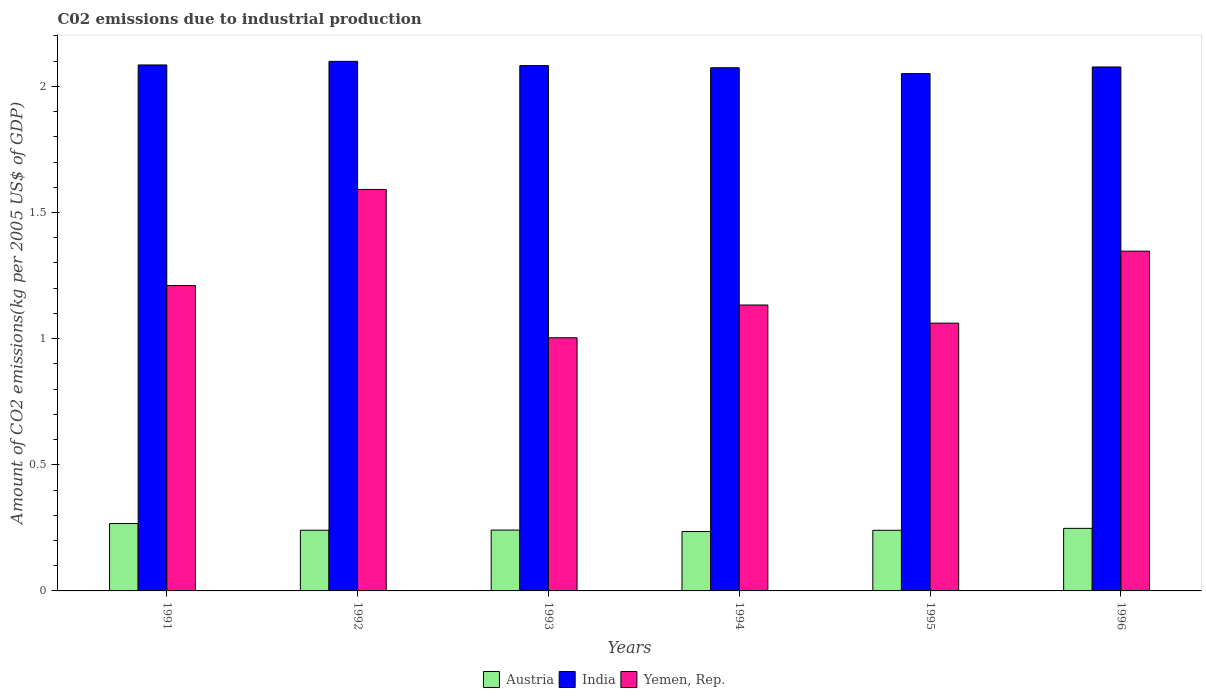How many different coloured bars are there?
Your answer should be very brief. 3. Are the number of bars on each tick of the X-axis equal?
Your response must be concise. Yes. What is the amount of CO2 emitted due to industrial production in Yemen, Rep. in 1994?
Offer a very short reply. 1.13. Across all years, what is the maximum amount of CO2 emitted due to industrial production in Yemen, Rep.?
Provide a succinct answer. 1.59. Across all years, what is the minimum amount of CO2 emitted due to industrial production in Yemen, Rep.?
Make the answer very short. 1. What is the total amount of CO2 emitted due to industrial production in India in the graph?
Provide a succinct answer. 12.47. What is the difference between the amount of CO2 emitted due to industrial production in India in 1992 and that in 1994?
Ensure brevity in your answer.  0.03. What is the difference between the amount of CO2 emitted due to industrial production in Austria in 1991 and the amount of CO2 emitted due to industrial production in India in 1995?
Your response must be concise. -1.78. What is the average amount of CO2 emitted due to industrial production in Yemen, Rep. per year?
Provide a short and direct response. 1.22. In the year 1992, what is the difference between the amount of CO2 emitted due to industrial production in India and amount of CO2 emitted due to industrial production in Austria?
Your response must be concise. 1.86. What is the ratio of the amount of CO2 emitted due to industrial production in Yemen, Rep. in 1992 to that in 1994?
Provide a short and direct response. 1.4. Is the amount of CO2 emitted due to industrial production in Yemen, Rep. in 1992 less than that in 1994?
Make the answer very short. No. Is the difference between the amount of CO2 emitted due to industrial production in India in 1991 and 1996 greater than the difference between the amount of CO2 emitted due to industrial production in Austria in 1991 and 1996?
Keep it short and to the point. No. What is the difference between the highest and the second highest amount of CO2 emitted due to industrial production in India?
Provide a succinct answer. 0.01. What is the difference between the highest and the lowest amount of CO2 emitted due to industrial production in Austria?
Provide a succinct answer. 0.03. In how many years, is the amount of CO2 emitted due to industrial production in Yemen, Rep. greater than the average amount of CO2 emitted due to industrial production in Yemen, Rep. taken over all years?
Your answer should be compact. 2. What does the 3rd bar from the left in 1996 represents?
Your answer should be very brief. Yemen, Rep. Is it the case that in every year, the sum of the amount of CO2 emitted due to industrial production in India and amount of CO2 emitted due to industrial production in Yemen, Rep. is greater than the amount of CO2 emitted due to industrial production in Austria?
Your answer should be compact. Yes. How many bars are there?
Keep it short and to the point. 18. Are all the bars in the graph horizontal?
Provide a short and direct response. No. How many years are there in the graph?
Provide a succinct answer. 6. What is the difference between two consecutive major ticks on the Y-axis?
Offer a terse response. 0.5. Does the graph contain any zero values?
Give a very brief answer. No. Where does the legend appear in the graph?
Provide a succinct answer. Bottom center. How are the legend labels stacked?
Your answer should be very brief. Horizontal. What is the title of the graph?
Ensure brevity in your answer.  C02 emissions due to industrial production. What is the label or title of the Y-axis?
Provide a succinct answer. Amount of CO2 emissions(kg per 2005 US$ of GDP). What is the Amount of CO2 emissions(kg per 2005 US$ of GDP) of Austria in 1991?
Offer a terse response. 0.27. What is the Amount of CO2 emissions(kg per 2005 US$ of GDP) in India in 1991?
Provide a succinct answer. 2.08. What is the Amount of CO2 emissions(kg per 2005 US$ of GDP) of Yemen, Rep. in 1991?
Offer a terse response. 1.21. What is the Amount of CO2 emissions(kg per 2005 US$ of GDP) in Austria in 1992?
Your answer should be compact. 0.24. What is the Amount of CO2 emissions(kg per 2005 US$ of GDP) in India in 1992?
Offer a terse response. 2.1. What is the Amount of CO2 emissions(kg per 2005 US$ of GDP) in Yemen, Rep. in 1992?
Keep it short and to the point. 1.59. What is the Amount of CO2 emissions(kg per 2005 US$ of GDP) in Austria in 1993?
Give a very brief answer. 0.24. What is the Amount of CO2 emissions(kg per 2005 US$ of GDP) in India in 1993?
Give a very brief answer. 2.08. What is the Amount of CO2 emissions(kg per 2005 US$ of GDP) in Yemen, Rep. in 1993?
Your answer should be compact. 1. What is the Amount of CO2 emissions(kg per 2005 US$ of GDP) in Austria in 1994?
Offer a terse response. 0.24. What is the Amount of CO2 emissions(kg per 2005 US$ of GDP) in India in 1994?
Make the answer very short. 2.07. What is the Amount of CO2 emissions(kg per 2005 US$ of GDP) in Yemen, Rep. in 1994?
Give a very brief answer. 1.13. What is the Amount of CO2 emissions(kg per 2005 US$ of GDP) in Austria in 1995?
Keep it short and to the point. 0.24. What is the Amount of CO2 emissions(kg per 2005 US$ of GDP) in India in 1995?
Your answer should be very brief. 2.05. What is the Amount of CO2 emissions(kg per 2005 US$ of GDP) in Yemen, Rep. in 1995?
Ensure brevity in your answer.  1.06. What is the Amount of CO2 emissions(kg per 2005 US$ of GDP) of Austria in 1996?
Offer a very short reply. 0.25. What is the Amount of CO2 emissions(kg per 2005 US$ of GDP) of India in 1996?
Your answer should be very brief. 2.08. What is the Amount of CO2 emissions(kg per 2005 US$ of GDP) of Yemen, Rep. in 1996?
Offer a terse response. 1.35. Across all years, what is the maximum Amount of CO2 emissions(kg per 2005 US$ of GDP) in Austria?
Your answer should be very brief. 0.27. Across all years, what is the maximum Amount of CO2 emissions(kg per 2005 US$ of GDP) of India?
Give a very brief answer. 2.1. Across all years, what is the maximum Amount of CO2 emissions(kg per 2005 US$ of GDP) in Yemen, Rep.?
Offer a very short reply. 1.59. Across all years, what is the minimum Amount of CO2 emissions(kg per 2005 US$ of GDP) in Austria?
Ensure brevity in your answer.  0.24. Across all years, what is the minimum Amount of CO2 emissions(kg per 2005 US$ of GDP) in India?
Provide a succinct answer. 2.05. Across all years, what is the minimum Amount of CO2 emissions(kg per 2005 US$ of GDP) in Yemen, Rep.?
Ensure brevity in your answer.  1. What is the total Amount of CO2 emissions(kg per 2005 US$ of GDP) in Austria in the graph?
Provide a short and direct response. 1.47. What is the total Amount of CO2 emissions(kg per 2005 US$ of GDP) in India in the graph?
Your response must be concise. 12.47. What is the total Amount of CO2 emissions(kg per 2005 US$ of GDP) in Yemen, Rep. in the graph?
Give a very brief answer. 7.35. What is the difference between the Amount of CO2 emissions(kg per 2005 US$ of GDP) of Austria in 1991 and that in 1992?
Keep it short and to the point. 0.03. What is the difference between the Amount of CO2 emissions(kg per 2005 US$ of GDP) in India in 1991 and that in 1992?
Your answer should be compact. -0.01. What is the difference between the Amount of CO2 emissions(kg per 2005 US$ of GDP) in Yemen, Rep. in 1991 and that in 1992?
Your response must be concise. -0.38. What is the difference between the Amount of CO2 emissions(kg per 2005 US$ of GDP) in Austria in 1991 and that in 1993?
Give a very brief answer. 0.03. What is the difference between the Amount of CO2 emissions(kg per 2005 US$ of GDP) in India in 1991 and that in 1993?
Your answer should be compact. 0. What is the difference between the Amount of CO2 emissions(kg per 2005 US$ of GDP) of Yemen, Rep. in 1991 and that in 1993?
Keep it short and to the point. 0.21. What is the difference between the Amount of CO2 emissions(kg per 2005 US$ of GDP) of Austria in 1991 and that in 1994?
Provide a short and direct response. 0.03. What is the difference between the Amount of CO2 emissions(kg per 2005 US$ of GDP) in India in 1991 and that in 1994?
Your answer should be very brief. 0.01. What is the difference between the Amount of CO2 emissions(kg per 2005 US$ of GDP) of Yemen, Rep. in 1991 and that in 1994?
Your answer should be very brief. 0.08. What is the difference between the Amount of CO2 emissions(kg per 2005 US$ of GDP) of Austria in 1991 and that in 1995?
Provide a succinct answer. 0.03. What is the difference between the Amount of CO2 emissions(kg per 2005 US$ of GDP) in India in 1991 and that in 1995?
Make the answer very short. 0.03. What is the difference between the Amount of CO2 emissions(kg per 2005 US$ of GDP) of Yemen, Rep. in 1991 and that in 1995?
Keep it short and to the point. 0.15. What is the difference between the Amount of CO2 emissions(kg per 2005 US$ of GDP) in Austria in 1991 and that in 1996?
Give a very brief answer. 0.02. What is the difference between the Amount of CO2 emissions(kg per 2005 US$ of GDP) of India in 1991 and that in 1996?
Keep it short and to the point. 0.01. What is the difference between the Amount of CO2 emissions(kg per 2005 US$ of GDP) in Yemen, Rep. in 1991 and that in 1996?
Provide a succinct answer. -0.14. What is the difference between the Amount of CO2 emissions(kg per 2005 US$ of GDP) of Austria in 1992 and that in 1993?
Ensure brevity in your answer.  -0. What is the difference between the Amount of CO2 emissions(kg per 2005 US$ of GDP) in India in 1992 and that in 1993?
Give a very brief answer. 0.02. What is the difference between the Amount of CO2 emissions(kg per 2005 US$ of GDP) in Yemen, Rep. in 1992 and that in 1993?
Give a very brief answer. 0.59. What is the difference between the Amount of CO2 emissions(kg per 2005 US$ of GDP) in Austria in 1992 and that in 1994?
Offer a terse response. 0.01. What is the difference between the Amount of CO2 emissions(kg per 2005 US$ of GDP) in India in 1992 and that in 1994?
Your response must be concise. 0.03. What is the difference between the Amount of CO2 emissions(kg per 2005 US$ of GDP) of Yemen, Rep. in 1992 and that in 1994?
Offer a terse response. 0.46. What is the difference between the Amount of CO2 emissions(kg per 2005 US$ of GDP) in India in 1992 and that in 1995?
Provide a succinct answer. 0.05. What is the difference between the Amount of CO2 emissions(kg per 2005 US$ of GDP) of Yemen, Rep. in 1992 and that in 1995?
Your response must be concise. 0.53. What is the difference between the Amount of CO2 emissions(kg per 2005 US$ of GDP) of Austria in 1992 and that in 1996?
Keep it short and to the point. -0.01. What is the difference between the Amount of CO2 emissions(kg per 2005 US$ of GDP) in India in 1992 and that in 1996?
Your answer should be compact. 0.02. What is the difference between the Amount of CO2 emissions(kg per 2005 US$ of GDP) in Yemen, Rep. in 1992 and that in 1996?
Ensure brevity in your answer.  0.24. What is the difference between the Amount of CO2 emissions(kg per 2005 US$ of GDP) in Austria in 1993 and that in 1994?
Keep it short and to the point. 0.01. What is the difference between the Amount of CO2 emissions(kg per 2005 US$ of GDP) of India in 1993 and that in 1994?
Provide a succinct answer. 0.01. What is the difference between the Amount of CO2 emissions(kg per 2005 US$ of GDP) in Yemen, Rep. in 1993 and that in 1994?
Offer a terse response. -0.13. What is the difference between the Amount of CO2 emissions(kg per 2005 US$ of GDP) in India in 1993 and that in 1995?
Make the answer very short. 0.03. What is the difference between the Amount of CO2 emissions(kg per 2005 US$ of GDP) in Yemen, Rep. in 1993 and that in 1995?
Provide a short and direct response. -0.06. What is the difference between the Amount of CO2 emissions(kg per 2005 US$ of GDP) in Austria in 1993 and that in 1996?
Provide a short and direct response. -0.01. What is the difference between the Amount of CO2 emissions(kg per 2005 US$ of GDP) in India in 1993 and that in 1996?
Ensure brevity in your answer.  0.01. What is the difference between the Amount of CO2 emissions(kg per 2005 US$ of GDP) in Yemen, Rep. in 1993 and that in 1996?
Make the answer very short. -0.34. What is the difference between the Amount of CO2 emissions(kg per 2005 US$ of GDP) in Austria in 1994 and that in 1995?
Offer a very short reply. -0. What is the difference between the Amount of CO2 emissions(kg per 2005 US$ of GDP) in India in 1994 and that in 1995?
Offer a terse response. 0.02. What is the difference between the Amount of CO2 emissions(kg per 2005 US$ of GDP) in Yemen, Rep. in 1994 and that in 1995?
Provide a short and direct response. 0.07. What is the difference between the Amount of CO2 emissions(kg per 2005 US$ of GDP) of Austria in 1994 and that in 1996?
Your answer should be very brief. -0.01. What is the difference between the Amount of CO2 emissions(kg per 2005 US$ of GDP) of India in 1994 and that in 1996?
Your answer should be very brief. -0. What is the difference between the Amount of CO2 emissions(kg per 2005 US$ of GDP) of Yemen, Rep. in 1994 and that in 1996?
Offer a terse response. -0.21. What is the difference between the Amount of CO2 emissions(kg per 2005 US$ of GDP) in Austria in 1995 and that in 1996?
Your answer should be compact. -0.01. What is the difference between the Amount of CO2 emissions(kg per 2005 US$ of GDP) in India in 1995 and that in 1996?
Give a very brief answer. -0.03. What is the difference between the Amount of CO2 emissions(kg per 2005 US$ of GDP) of Yemen, Rep. in 1995 and that in 1996?
Your response must be concise. -0.29. What is the difference between the Amount of CO2 emissions(kg per 2005 US$ of GDP) in Austria in 1991 and the Amount of CO2 emissions(kg per 2005 US$ of GDP) in India in 1992?
Keep it short and to the point. -1.83. What is the difference between the Amount of CO2 emissions(kg per 2005 US$ of GDP) in Austria in 1991 and the Amount of CO2 emissions(kg per 2005 US$ of GDP) in Yemen, Rep. in 1992?
Your answer should be very brief. -1.32. What is the difference between the Amount of CO2 emissions(kg per 2005 US$ of GDP) of India in 1991 and the Amount of CO2 emissions(kg per 2005 US$ of GDP) of Yemen, Rep. in 1992?
Provide a short and direct response. 0.49. What is the difference between the Amount of CO2 emissions(kg per 2005 US$ of GDP) in Austria in 1991 and the Amount of CO2 emissions(kg per 2005 US$ of GDP) in India in 1993?
Your answer should be very brief. -1.81. What is the difference between the Amount of CO2 emissions(kg per 2005 US$ of GDP) of Austria in 1991 and the Amount of CO2 emissions(kg per 2005 US$ of GDP) of Yemen, Rep. in 1993?
Your answer should be very brief. -0.74. What is the difference between the Amount of CO2 emissions(kg per 2005 US$ of GDP) in India in 1991 and the Amount of CO2 emissions(kg per 2005 US$ of GDP) in Yemen, Rep. in 1993?
Your answer should be compact. 1.08. What is the difference between the Amount of CO2 emissions(kg per 2005 US$ of GDP) in Austria in 1991 and the Amount of CO2 emissions(kg per 2005 US$ of GDP) in India in 1994?
Ensure brevity in your answer.  -1.81. What is the difference between the Amount of CO2 emissions(kg per 2005 US$ of GDP) in Austria in 1991 and the Amount of CO2 emissions(kg per 2005 US$ of GDP) in Yemen, Rep. in 1994?
Keep it short and to the point. -0.87. What is the difference between the Amount of CO2 emissions(kg per 2005 US$ of GDP) of India in 1991 and the Amount of CO2 emissions(kg per 2005 US$ of GDP) of Yemen, Rep. in 1994?
Make the answer very short. 0.95. What is the difference between the Amount of CO2 emissions(kg per 2005 US$ of GDP) in Austria in 1991 and the Amount of CO2 emissions(kg per 2005 US$ of GDP) in India in 1995?
Your answer should be compact. -1.78. What is the difference between the Amount of CO2 emissions(kg per 2005 US$ of GDP) in Austria in 1991 and the Amount of CO2 emissions(kg per 2005 US$ of GDP) in Yemen, Rep. in 1995?
Offer a terse response. -0.79. What is the difference between the Amount of CO2 emissions(kg per 2005 US$ of GDP) of India in 1991 and the Amount of CO2 emissions(kg per 2005 US$ of GDP) of Yemen, Rep. in 1995?
Provide a short and direct response. 1.02. What is the difference between the Amount of CO2 emissions(kg per 2005 US$ of GDP) of Austria in 1991 and the Amount of CO2 emissions(kg per 2005 US$ of GDP) of India in 1996?
Ensure brevity in your answer.  -1.81. What is the difference between the Amount of CO2 emissions(kg per 2005 US$ of GDP) of Austria in 1991 and the Amount of CO2 emissions(kg per 2005 US$ of GDP) of Yemen, Rep. in 1996?
Your response must be concise. -1.08. What is the difference between the Amount of CO2 emissions(kg per 2005 US$ of GDP) of India in 1991 and the Amount of CO2 emissions(kg per 2005 US$ of GDP) of Yemen, Rep. in 1996?
Your answer should be compact. 0.74. What is the difference between the Amount of CO2 emissions(kg per 2005 US$ of GDP) in Austria in 1992 and the Amount of CO2 emissions(kg per 2005 US$ of GDP) in India in 1993?
Give a very brief answer. -1.84. What is the difference between the Amount of CO2 emissions(kg per 2005 US$ of GDP) of Austria in 1992 and the Amount of CO2 emissions(kg per 2005 US$ of GDP) of Yemen, Rep. in 1993?
Your answer should be very brief. -0.76. What is the difference between the Amount of CO2 emissions(kg per 2005 US$ of GDP) of India in 1992 and the Amount of CO2 emissions(kg per 2005 US$ of GDP) of Yemen, Rep. in 1993?
Provide a short and direct response. 1.1. What is the difference between the Amount of CO2 emissions(kg per 2005 US$ of GDP) in Austria in 1992 and the Amount of CO2 emissions(kg per 2005 US$ of GDP) in India in 1994?
Offer a terse response. -1.83. What is the difference between the Amount of CO2 emissions(kg per 2005 US$ of GDP) in Austria in 1992 and the Amount of CO2 emissions(kg per 2005 US$ of GDP) in Yemen, Rep. in 1994?
Your answer should be compact. -0.89. What is the difference between the Amount of CO2 emissions(kg per 2005 US$ of GDP) of India in 1992 and the Amount of CO2 emissions(kg per 2005 US$ of GDP) of Yemen, Rep. in 1994?
Your response must be concise. 0.97. What is the difference between the Amount of CO2 emissions(kg per 2005 US$ of GDP) of Austria in 1992 and the Amount of CO2 emissions(kg per 2005 US$ of GDP) of India in 1995?
Offer a terse response. -1.81. What is the difference between the Amount of CO2 emissions(kg per 2005 US$ of GDP) in Austria in 1992 and the Amount of CO2 emissions(kg per 2005 US$ of GDP) in Yemen, Rep. in 1995?
Offer a very short reply. -0.82. What is the difference between the Amount of CO2 emissions(kg per 2005 US$ of GDP) in India in 1992 and the Amount of CO2 emissions(kg per 2005 US$ of GDP) in Yemen, Rep. in 1995?
Make the answer very short. 1.04. What is the difference between the Amount of CO2 emissions(kg per 2005 US$ of GDP) in Austria in 1992 and the Amount of CO2 emissions(kg per 2005 US$ of GDP) in India in 1996?
Give a very brief answer. -1.84. What is the difference between the Amount of CO2 emissions(kg per 2005 US$ of GDP) in Austria in 1992 and the Amount of CO2 emissions(kg per 2005 US$ of GDP) in Yemen, Rep. in 1996?
Ensure brevity in your answer.  -1.11. What is the difference between the Amount of CO2 emissions(kg per 2005 US$ of GDP) of India in 1992 and the Amount of CO2 emissions(kg per 2005 US$ of GDP) of Yemen, Rep. in 1996?
Provide a short and direct response. 0.75. What is the difference between the Amount of CO2 emissions(kg per 2005 US$ of GDP) in Austria in 1993 and the Amount of CO2 emissions(kg per 2005 US$ of GDP) in India in 1994?
Make the answer very short. -1.83. What is the difference between the Amount of CO2 emissions(kg per 2005 US$ of GDP) in Austria in 1993 and the Amount of CO2 emissions(kg per 2005 US$ of GDP) in Yemen, Rep. in 1994?
Offer a terse response. -0.89. What is the difference between the Amount of CO2 emissions(kg per 2005 US$ of GDP) in India in 1993 and the Amount of CO2 emissions(kg per 2005 US$ of GDP) in Yemen, Rep. in 1994?
Your response must be concise. 0.95. What is the difference between the Amount of CO2 emissions(kg per 2005 US$ of GDP) of Austria in 1993 and the Amount of CO2 emissions(kg per 2005 US$ of GDP) of India in 1995?
Your response must be concise. -1.81. What is the difference between the Amount of CO2 emissions(kg per 2005 US$ of GDP) in Austria in 1993 and the Amount of CO2 emissions(kg per 2005 US$ of GDP) in Yemen, Rep. in 1995?
Offer a very short reply. -0.82. What is the difference between the Amount of CO2 emissions(kg per 2005 US$ of GDP) of India in 1993 and the Amount of CO2 emissions(kg per 2005 US$ of GDP) of Yemen, Rep. in 1995?
Ensure brevity in your answer.  1.02. What is the difference between the Amount of CO2 emissions(kg per 2005 US$ of GDP) of Austria in 1993 and the Amount of CO2 emissions(kg per 2005 US$ of GDP) of India in 1996?
Offer a terse response. -1.84. What is the difference between the Amount of CO2 emissions(kg per 2005 US$ of GDP) of Austria in 1993 and the Amount of CO2 emissions(kg per 2005 US$ of GDP) of Yemen, Rep. in 1996?
Provide a short and direct response. -1.11. What is the difference between the Amount of CO2 emissions(kg per 2005 US$ of GDP) of India in 1993 and the Amount of CO2 emissions(kg per 2005 US$ of GDP) of Yemen, Rep. in 1996?
Give a very brief answer. 0.74. What is the difference between the Amount of CO2 emissions(kg per 2005 US$ of GDP) in Austria in 1994 and the Amount of CO2 emissions(kg per 2005 US$ of GDP) in India in 1995?
Make the answer very short. -1.81. What is the difference between the Amount of CO2 emissions(kg per 2005 US$ of GDP) in Austria in 1994 and the Amount of CO2 emissions(kg per 2005 US$ of GDP) in Yemen, Rep. in 1995?
Provide a succinct answer. -0.83. What is the difference between the Amount of CO2 emissions(kg per 2005 US$ of GDP) in India in 1994 and the Amount of CO2 emissions(kg per 2005 US$ of GDP) in Yemen, Rep. in 1995?
Ensure brevity in your answer.  1.01. What is the difference between the Amount of CO2 emissions(kg per 2005 US$ of GDP) in Austria in 1994 and the Amount of CO2 emissions(kg per 2005 US$ of GDP) in India in 1996?
Keep it short and to the point. -1.84. What is the difference between the Amount of CO2 emissions(kg per 2005 US$ of GDP) of Austria in 1994 and the Amount of CO2 emissions(kg per 2005 US$ of GDP) of Yemen, Rep. in 1996?
Your answer should be compact. -1.11. What is the difference between the Amount of CO2 emissions(kg per 2005 US$ of GDP) of India in 1994 and the Amount of CO2 emissions(kg per 2005 US$ of GDP) of Yemen, Rep. in 1996?
Make the answer very short. 0.73. What is the difference between the Amount of CO2 emissions(kg per 2005 US$ of GDP) in Austria in 1995 and the Amount of CO2 emissions(kg per 2005 US$ of GDP) in India in 1996?
Offer a terse response. -1.84. What is the difference between the Amount of CO2 emissions(kg per 2005 US$ of GDP) in Austria in 1995 and the Amount of CO2 emissions(kg per 2005 US$ of GDP) in Yemen, Rep. in 1996?
Your answer should be very brief. -1.11. What is the difference between the Amount of CO2 emissions(kg per 2005 US$ of GDP) in India in 1995 and the Amount of CO2 emissions(kg per 2005 US$ of GDP) in Yemen, Rep. in 1996?
Your response must be concise. 0.7. What is the average Amount of CO2 emissions(kg per 2005 US$ of GDP) in Austria per year?
Provide a succinct answer. 0.25. What is the average Amount of CO2 emissions(kg per 2005 US$ of GDP) in India per year?
Make the answer very short. 2.08. What is the average Amount of CO2 emissions(kg per 2005 US$ of GDP) in Yemen, Rep. per year?
Ensure brevity in your answer.  1.22. In the year 1991, what is the difference between the Amount of CO2 emissions(kg per 2005 US$ of GDP) in Austria and Amount of CO2 emissions(kg per 2005 US$ of GDP) in India?
Your response must be concise. -1.82. In the year 1991, what is the difference between the Amount of CO2 emissions(kg per 2005 US$ of GDP) of Austria and Amount of CO2 emissions(kg per 2005 US$ of GDP) of Yemen, Rep.?
Provide a succinct answer. -0.94. In the year 1991, what is the difference between the Amount of CO2 emissions(kg per 2005 US$ of GDP) in India and Amount of CO2 emissions(kg per 2005 US$ of GDP) in Yemen, Rep.?
Your answer should be very brief. 0.87. In the year 1992, what is the difference between the Amount of CO2 emissions(kg per 2005 US$ of GDP) of Austria and Amount of CO2 emissions(kg per 2005 US$ of GDP) of India?
Make the answer very short. -1.86. In the year 1992, what is the difference between the Amount of CO2 emissions(kg per 2005 US$ of GDP) in Austria and Amount of CO2 emissions(kg per 2005 US$ of GDP) in Yemen, Rep.?
Make the answer very short. -1.35. In the year 1992, what is the difference between the Amount of CO2 emissions(kg per 2005 US$ of GDP) in India and Amount of CO2 emissions(kg per 2005 US$ of GDP) in Yemen, Rep.?
Offer a very short reply. 0.51. In the year 1993, what is the difference between the Amount of CO2 emissions(kg per 2005 US$ of GDP) of Austria and Amount of CO2 emissions(kg per 2005 US$ of GDP) of India?
Keep it short and to the point. -1.84. In the year 1993, what is the difference between the Amount of CO2 emissions(kg per 2005 US$ of GDP) of Austria and Amount of CO2 emissions(kg per 2005 US$ of GDP) of Yemen, Rep.?
Your response must be concise. -0.76. In the year 1993, what is the difference between the Amount of CO2 emissions(kg per 2005 US$ of GDP) in India and Amount of CO2 emissions(kg per 2005 US$ of GDP) in Yemen, Rep.?
Provide a succinct answer. 1.08. In the year 1994, what is the difference between the Amount of CO2 emissions(kg per 2005 US$ of GDP) in Austria and Amount of CO2 emissions(kg per 2005 US$ of GDP) in India?
Make the answer very short. -1.84. In the year 1994, what is the difference between the Amount of CO2 emissions(kg per 2005 US$ of GDP) in Austria and Amount of CO2 emissions(kg per 2005 US$ of GDP) in Yemen, Rep.?
Keep it short and to the point. -0.9. In the year 1994, what is the difference between the Amount of CO2 emissions(kg per 2005 US$ of GDP) of India and Amount of CO2 emissions(kg per 2005 US$ of GDP) of Yemen, Rep.?
Provide a succinct answer. 0.94. In the year 1995, what is the difference between the Amount of CO2 emissions(kg per 2005 US$ of GDP) of Austria and Amount of CO2 emissions(kg per 2005 US$ of GDP) of India?
Offer a very short reply. -1.81. In the year 1995, what is the difference between the Amount of CO2 emissions(kg per 2005 US$ of GDP) in Austria and Amount of CO2 emissions(kg per 2005 US$ of GDP) in Yemen, Rep.?
Give a very brief answer. -0.82. In the year 1996, what is the difference between the Amount of CO2 emissions(kg per 2005 US$ of GDP) of Austria and Amount of CO2 emissions(kg per 2005 US$ of GDP) of India?
Keep it short and to the point. -1.83. In the year 1996, what is the difference between the Amount of CO2 emissions(kg per 2005 US$ of GDP) in Austria and Amount of CO2 emissions(kg per 2005 US$ of GDP) in Yemen, Rep.?
Your answer should be compact. -1.1. In the year 1996, what is the difference between the Amount of CO2 emissions(kg per 2005 US$ of GDP) of India and Amount of CO2 emissions(kg per 2005 US$ of GDP) of Yemen, Rep.?
Provide a succinct answer. 0.73. What is the ratio of the Amount of CO2 emissions(kg per 2005 US$ of GDP) of Austria in 1991 to that in 1992?
Offer a very short reply. 1.11. What is the ratio of the Amount of CO2 emissions(kg per 2005 US$ of GDP) of India in 1991 to that in 1992?
Make the answer very short. 0.99. What is the ratio of the Amount of CO2 emissions(kg per 2005 US$ of GDP) of Yemen, Rep. in 1991 to that in 1992?
Provide a succinct answer. 0.76. What is the ratio of the Amount of CO2 emissions(kg per 2005 US$ of GDP) in Austria in 1991 to that in 1993?
Your answer should be very brief. 1.11. What is the ratio of the Amount of CO2 emissions(kg per 2005 US$ of GDP) in Yemen, Rep. in 1991 to that in 1993?
Offer a terse response. 1.21. What is the ratio of the Amount of CO2 emissions(kg per 2005 US$ of GDP) of Austria in 1991 to that in 1994?
Keep it short and to the point. 1.13. What is the ratio of the Amount of CO2 emissions(kg per 2005 US$ of GDP) of India in 1991 to that in 1994?
Your response must be concise. 1.01. What is the ratio of the Amount of CO2 emissions(kg per 2005 US$ of GDP) of Yemen, Rep. in 1991 to that in 1994?
Provide a short and direct response. 1.07. What is the ratio of the Amount of CO2 emissions(kg per 2005 US$ of GDP) of Austria in 1991 to that in 1995?
Give a very brief answer. 1.11. What is the ratio of the Amount of CO2 emissions(kg per 2005 US$ of GDP) in India in 1991 to that in 1995?
Provide a short and direct response. 1.02. What is the ratio of the Amount of CO2 emissions(kg per 2005 US$ of GDP) of Yemen, Rep. in 1991 to that in 1995?
Provide a succinct answer. 1.14. What is the ratio of the Amount of CO2 emissions(kg per 2005 US$ of GDP) of Austria in 1991 to that in 1996?
Your answer should be very brief. 1.08. What is the ratio of the Amount of CO2 emissions(kg per 2005 US$ of GDP) in Yemen, Rep. in 1991 to that in 1996?
Offer a very short reply. 0.9. What is the ratio of the Amount of CO2 emissions(kg per 2005 US$ of GDP) in Yemen, Rep. in 1992 to that in 1993?
Give a very brief answer. 1.59. What is the ratio of the Amount of CO2 emissions(kg per 2005 US$ of GDP) in Austria in 1992 to that in 1994?
Your answer should be compact. 1.02. What is the ratio of the Amount of CO2 emissions(kg per 2005 US$ of GDP) in India in 1992 to that in 1994?
Your response must be concise. 1.01. What is the ratio of the Amount of CO2 emissions(kg per 2005 US$ of GDP) in Yemen, Rep. in 1992 to that in 1994?
Offer a very short reply. 1.4. What is the ratio of the Amount of CO2 emissions(kg per 2005 US$ of GDP) in India in 1992 to that in 1995?
Offer a very short reply. 1.02. What is the ratio of the Amount of CO2 emissions(kg per 2005 US$ of GDP) in Yemen, Rep. in 1992 to that in 1995?
Your answer should be very brief. 1.5. What is the ratio of the Amount of CO2 emissions(kg per 2005 US$ of GDP) in Austria in 1992 to that in 1996?
Provide a succinct answer. 0.97. What is the ratio of the Amount of CO2 emissions(kg per 2005 US$ of GDP) in India in 1992 to that in 1996?
Your answer should be compact. 1.01. What is the ratio of the Amount of CO2 emissions(kg per 2005 US$ of GDP) of Yemen, Rep. in 1992 to that in 1996?
Your answer should be very brief. 1.18. What is the ratio of the Amount of CO2 emissions(kg per 2005 US$ of GDP) in Austria in 1993 to that in 1994?
Offer a very short reply. 1.02. What is the ratio of the Amount of CO2 emissions(kg per 2005 US$ of GDP) in India in 1993 to that in 1994?
Provide a succinct answer. 1. What is the ratio of the Amount of CO2 emissions(kg per 2005 US$ of GDP) of Yemen, Rep. in 1993 to that in 1994?
Your response must be concise. 0.89. What is the ratio of the Amount of CO2 emissions(kg per 2005 US$ of GDP) in Austria in 1993 to that in 1995?
Your response must be concise. 1. What is the ratio of the Amount of CO2 emissions(kg per 2005 US$ of GDP) of India in 1993 to that in 1995?
Ensure brevity in your answer.  1.02. What is the ratio of the Amount of CO2 emissions(kg per 2005 US$ of GDP) of Yemen, Rep. in 1993 to that in 1995?
Ensure brevity in your answer.  0.95. What is the ratio of the Amount of CO2 emissions(kg per 2005 US$ of GDP) in Austria in 1993 to that in 1996?
Make the answer very short. 0.97. What is the ratio of the Amount of CO2 emissions(kg per 2005 US$ of GDP) of Yemen, Rep. in 1993 to that in 1996?
Your answer should be compact. 0.75. What is the ratio of the Amount of CO2 emissions(kg per 2005 US$ of GDP) in Austria in 1994 to that in 1995?
Your answer should be very brief. 0.98. What is the ratio of the Amount of CO2 emissions(kg per 2005 US$ of GDP) in India in 1994 to that in 1995?
Offer a very short reply. 1.01. What is the ratio of the Amount of CO2 emissions(kg per 2005 US$ of GDP) of Yemen, Rep. in 1994 to that in 1995?
Offer a very short reply. 1.07. What is the ratio of the Amount of CO2 emissions(kg per 2005 US$ of GDP) in Austria in 1994 to that in 1996?
Provide a succinct answer. 0.95. What is the ratio of the Amount of CO2 emissions(kg per 2005 US$ of GDP) in India in 1994 to that in 1996?
Keep it short and to the point. 1. What is the ratio of the Amount of CO2 emissions(kg per 2005 US$ of GDP) in Yemen, Rep. in 1994 to that in 1996?
Offer a terse response. 0.84. What is the ratio of the Amount of CO2 emissions(kg per 2005 US$ of GDP) of Austria in 1995 to that in 1996?
Offer a very short reply. 0.97. What is the ratio of the Amount of CO2 emissions(kg per 2005 US$ of GDP) of India in 1995 to that in 1996?
Make the answer very short. 0.99. What is the ratio of the Amount of CO2 emissions(kg per 2005 US$ of GDP) of Yemen, Rep. in 1995 to that in 1996?
Provide a short and direct response. 0.79. What is the difference between the highest and the second highest Amount of CO2 emissions(kg per 2005 US$ of GDP) of Austria?
Offer a terse response. 0.02. What is the difference between the highest and the second highest Amount of CO2 emissions(kg per 2005 US$ of GDP) in India?
Your answer should be compact. 0.01. What is the difference between the highest and the second highest Amount of CO2 emissions(kg per 2005 US$ of GDP) in Yemen, Rep.?
Provide a short and direct response. 0.24. What is the difference between the highest and the lowest Amount of CO2 emissions(kg per 2005 US$ of GDP) of Austria?
Make the answer very short. 0.03. What is the difference between the highest and the lowest Amount of CO2 emissions(kg per 2005 US$ of GDP) in India?
Offer a terse response. 0.05. What is the difference between the highest and the lowest Amount of CO2 emissions(kg per 2005 US$ of GDP) in Yemen, Rep.?
Make the answer very short. 0.59. 